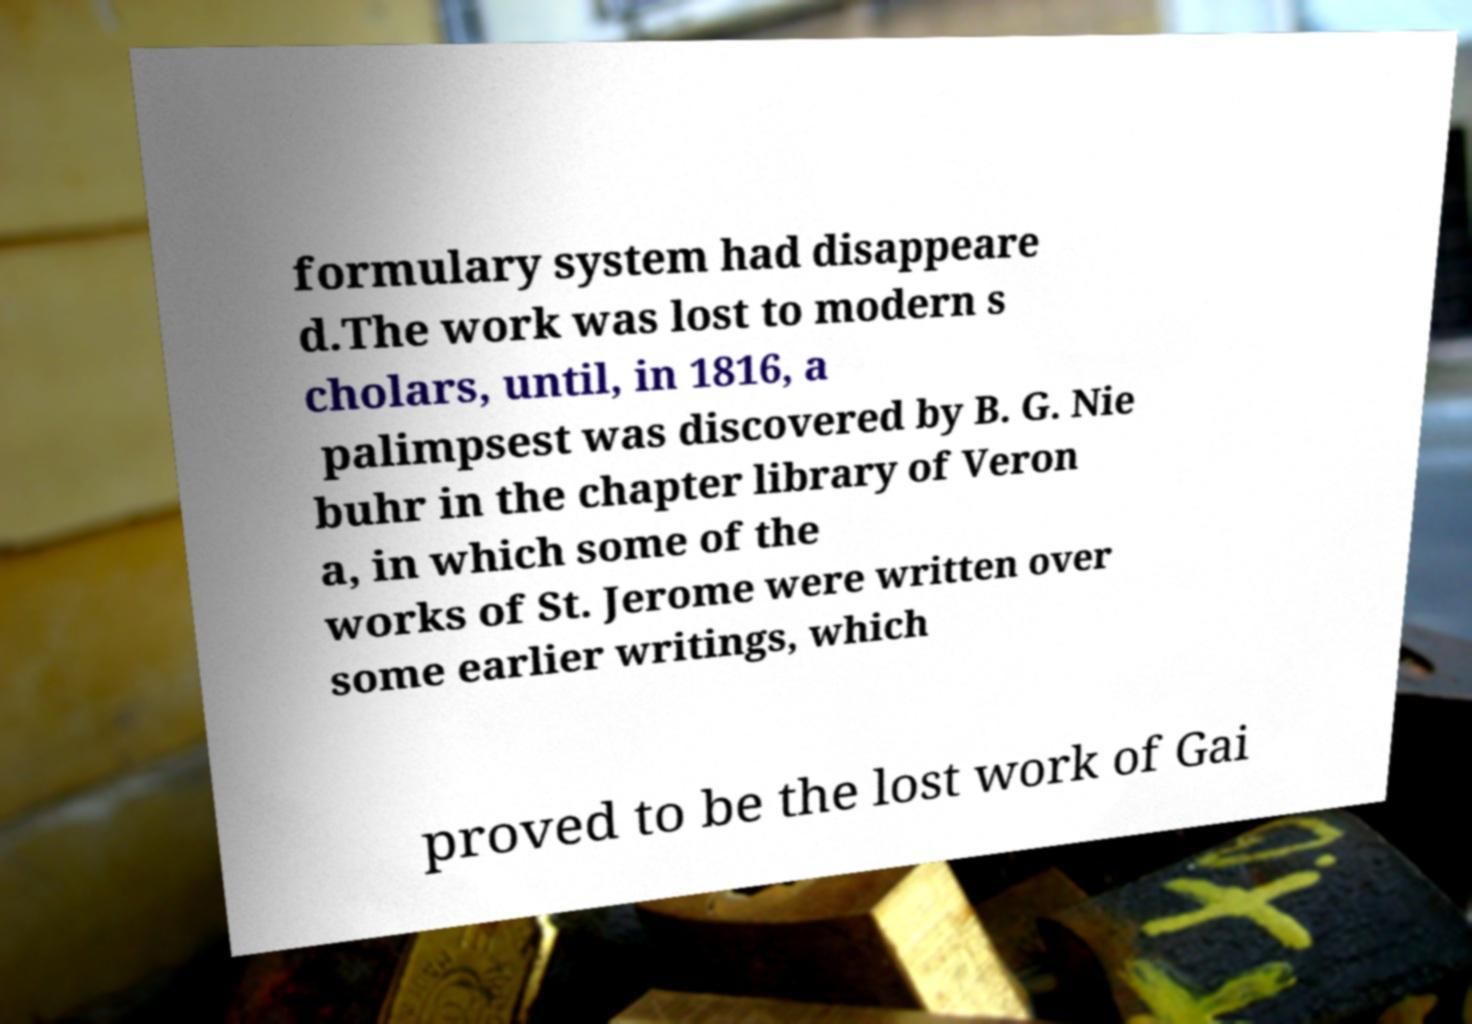What messages or text are displayed in this image? I need them in a readable, typed format. formulary system had disappeare d.The work was lost to modern s cholars, until, in 1816, a palimpsest was discovered by B. G. Nie buhr in the chapter library of Veron a, in which some of the works of St. Jerome were written over some earlier writings, which proved to be the lost work of Gai 